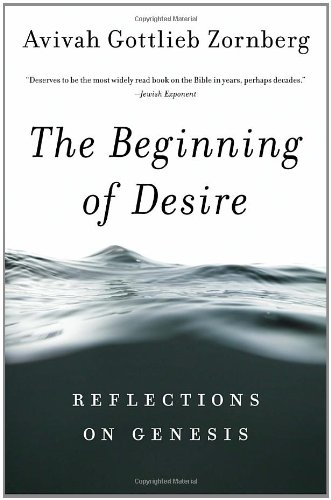Can you explain the significance of the book's cover design? The cover features serene water imagery, symbolizing the formative and often turbulent waters of creation described in Genesis, reflecting the book's deep exploration of creation themes and their existential implications. 